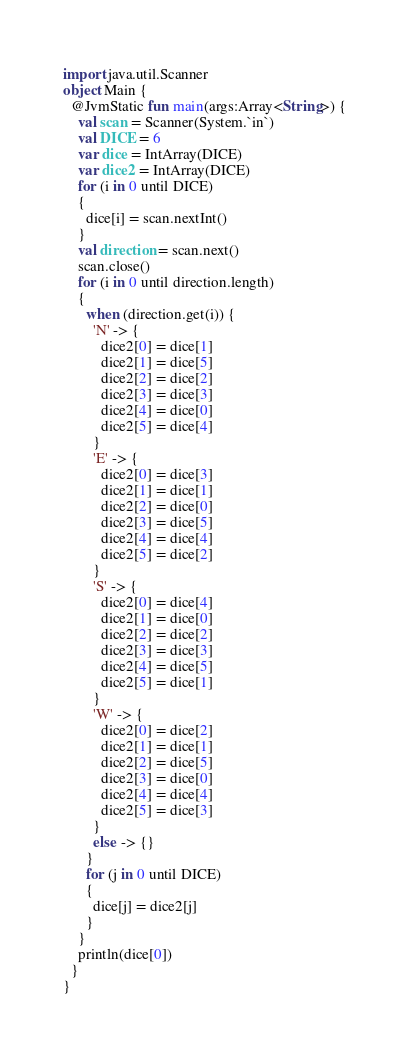<code> <loc_0><loc_0><loc_500><loc_500><_Kotlin_>import java.util.Scanner
object Main {
  @JvmStatic fun main(args:Array<String>) {
    val scan = Scanner(System.`in`)
    val DICE = 6
    var dice = IntArray(DICE)
    var dice2 = IntArray(DICE)
    for (i in 0 until DICE)
    {
      dice[i] = scan.nextInt()
    }
    val direction = scan.next()
    scan.close()
    for (i in 0 until direction.length)
    {
      when (direction.get(i)) {
        'N' -> {
          dice2[0] = dice[1]
          dice2[1] = dice[5]
          dice2[2] = dice[2]
          dice2[3] = dice[3]
          dice2[4] = dice[0]
          dice2[5] = dice[4]
        }
        'E' -> {
          dice2[0] = dice[3]
          dice2[1] = dice[1]
          dice2[2] = dice[0]
          dice2[3] = dice[5]
          dice2[4] = dice[4]
          dice2[5] = dice[2]
        }
        'S' -> {
          dice2[0] = dice[4]
          dice2[1] = dice[0]
          dice2[2] = dice[2]
          dice2[3] = dice[3]
          dice2[4] = dice[5]
          dice2[5] = dice[1]
        }
        'W' -> {
          dice2[0] = dice[2]
          dice2[1] = dice[1]
          dice2[2] = dice[5]
          dice2[3] = dice[0]
          dice2[4] = dice[4]
          dice2[5] = dice[3]
        }
        else -> {}
      }
      for (j in 0 until DICE)
      {
        dice[j] = dice2[j]
      }
    }
    println(dice[0])
  }
}
</code> 